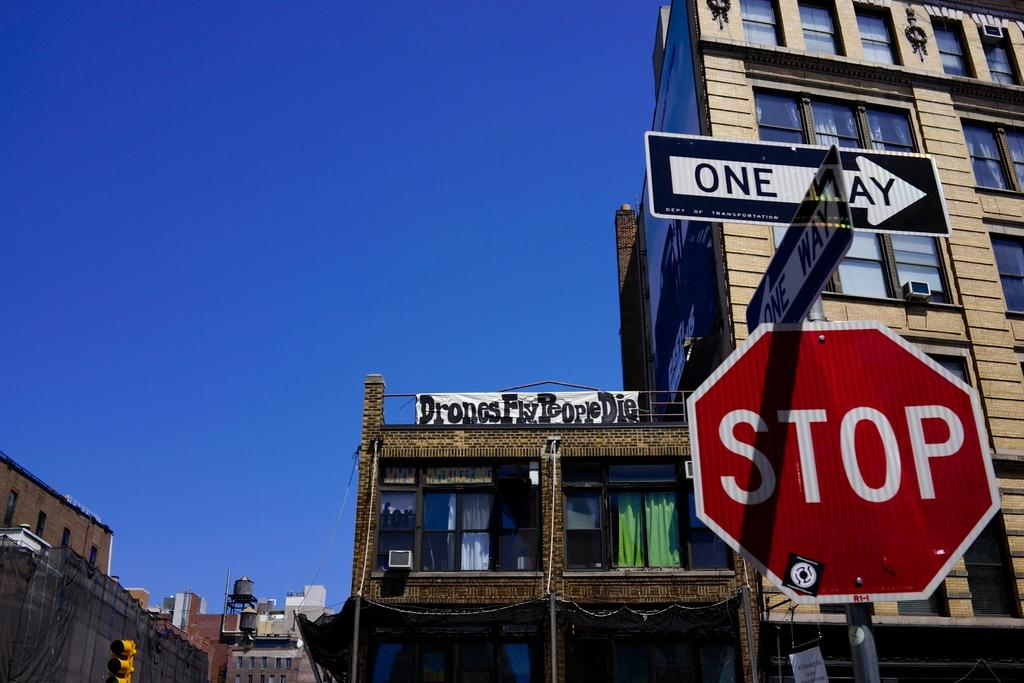<image>
Provide a brief description of the given image. A white and red stop sign has a black and white one way sign on the top of it. 